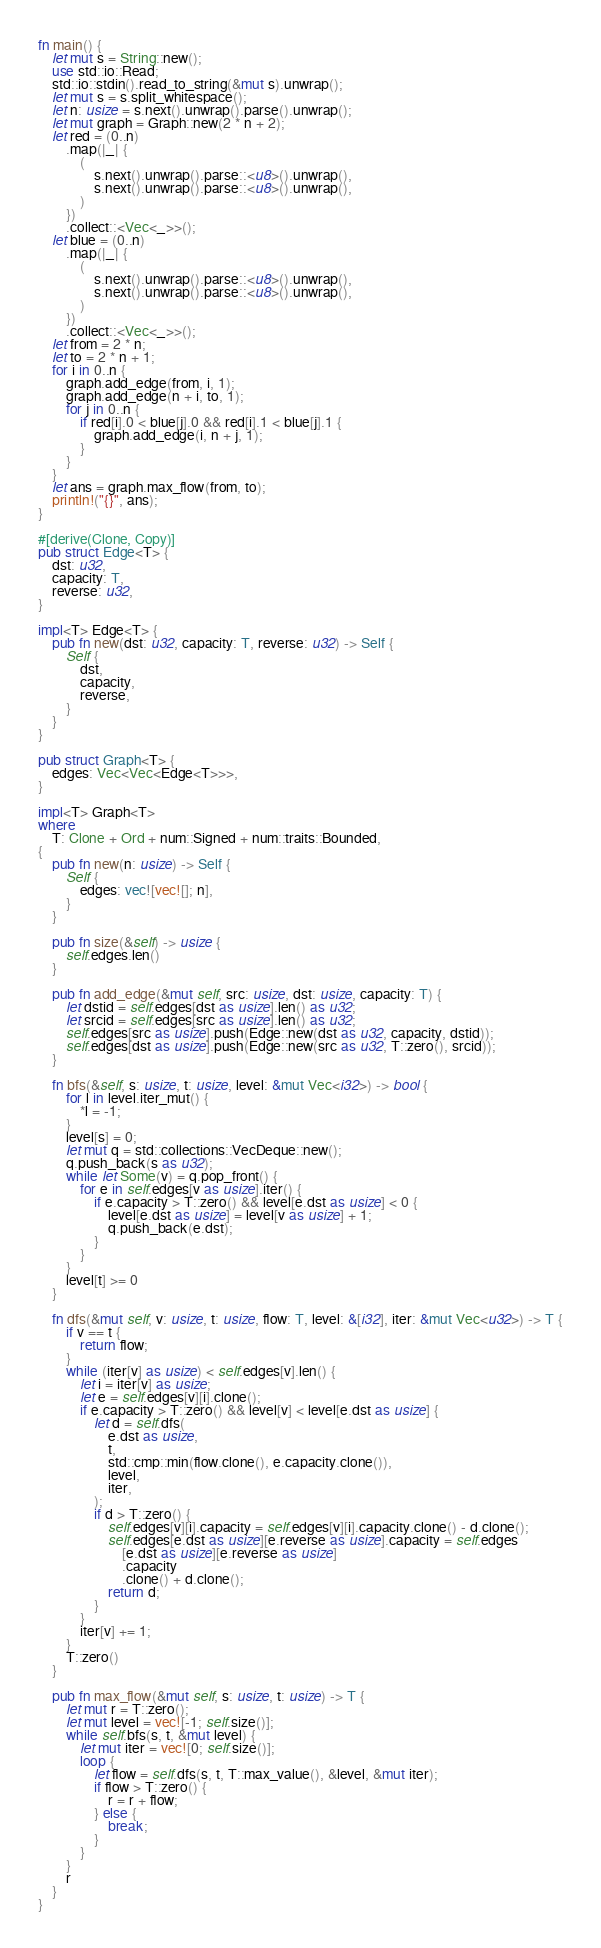<code> <loc_0><loc_0><loc_500><loc_500><_Rust_>fn main() {
	let mut s = String::new();
	use std::io::Read;
	std::io::stdin().read_to_string(&mut s).unwrap();
	let mut s = s.split_whitespace();
	let n: usize = s.next().unwrap().parse().unwrap();
	let mut graph = Graph::new(2 * n + 2);
	let red = (0..n)
		.map(|_| {
			(
				s.next().unwrap().parse::<u8>().unwrap(),
				s.next().unwrap().parse::<u8>().unwrap(),
			)
		})
		.collect::<Vec<_>>();
	let blue = (0..n)
		.map(|_| {
			(
				s.next().unwrap().parse::<u8>().unwrap(),
				s.next().unwrap().parse::<u8>().unwrap(),
			)
		})
		.collect::<Vec<_>>();
	let from = 2 * n;
	let to = 2 * n + 1;
	for i in 0..n {
		graph.add_edge(from, i, 1);
		graph.add_edge(n + i, to, 1);
		for j in 0..n {
			if red[i].0 < blue[j].0 && red[i].1 < blue[j].1 {
				graph.add_edge(i, n + j, 1);
			}
		}
	}
	let ans = graph.max_flow(from, to);
	println!("{}", ans);
}

#[derive(Clone, Copy)]
pub struct Edge<T> {
	dst: u32,
	capacity: T,
	reverse: u32,
}

impl<T> Edge<T> {
	pub fn new(dst: u32, capacity: T, reverse: u32) -> Self {
		Self {
			dst,
			capacity,
			reverse,
		}
	}
}

pub struct Graph<T> {
	edges: Vec<Vec<Edge<T>>>,
}

impl<T> Graph<T>
where
	T: Clone + Ord + num::Signed + num::traits::Bounded,
{
	pub fn new(n: usize) -> Self {
		Self {
			edges: vec![vec![]; n],
		}
	}

	pub fn size(&self) -> usize {
		self.edges.len()
	}

	pub fn add_edge(&mut self, src: usize, dst: usize, capacity: T) {
		let dstid = self.edges[dst as usize].len() as u32;
		let srcid = self.edges[src as usize].len() as u32;
		self.edges[src as usize].push(Edge::new(dst as u32, capacity, dstid));
		self.edges[dst as usize].push(Edge::new(src as u32, T::zero(), srcid));
	}

	fn bfs(&self, s: usize, t: usize, level: &mut Vec<i32>) -> bool {
		for l in level.iter_mut() {
			*l = -1;
		}
		level[s] = 0;
		let mut q = std::collections::VecDeque::new();
		q.push_back(s as u32);
		while let Some(v) = q.pop_front() {
			for e in self.edges[v as usize].iter() {
				if e.capacity > T::zero() && level[e.dst as usize] < 0 {
					level[e.dst as usize] = level[v as usize] + 1;
					q.push_back(e.dst);
				}
			}
		}
		level[t] >= 0
	}

	fn dfs(&mut self, v: usize, t: usize, flow: T, level: &[i32], iter: &mut Vec<u32>) -> T {
		if v == t {
			return flow;
		}
		while (iter[v] as usize) < self.edges[v].len() {
			let i = iter[v] as usize;
			let e = self.edges[v][i].clone();
			if e.capacity > T::zero() && level[v] < level[e.dst as usize] {
				let d = self.dfs(
					e.dst as usize,
					t,
					std::cmp::min(flow.clone(), e.capacity.clone()),
					level,
					iter,
				);
				if d > T::zero() {
					self.edges[v][i].capacity = self.edges[v][i].capacity.clone() - d.clone();
					self.edges[e.dst as usize][e.reverse as usize].capacity = self.edges
						[e.dst as usize][e.reverse as usize]
						.capacity
						.clone() + d.clone();
					return d;
				}
			}
			iter[v] += 1;
		}
		T::zero()
	}

	pub fn max_flow(&mut self, s: usize, t: usize) -> T {
		let mut r = T::zero();
		let mut level = vec![-1; self.size()];
		while self.bfs(s, t, &mut level) {
			let mut iter = vec![0; self.size()];
			loop {
				let flow = self.dfs(s, t, T::max_value(), &level, &mut iter);
				if flow > T::zero() {
					r = r + flow;
				} else {
					break;
				}
			}
		}
		r
	}
}
</code> 